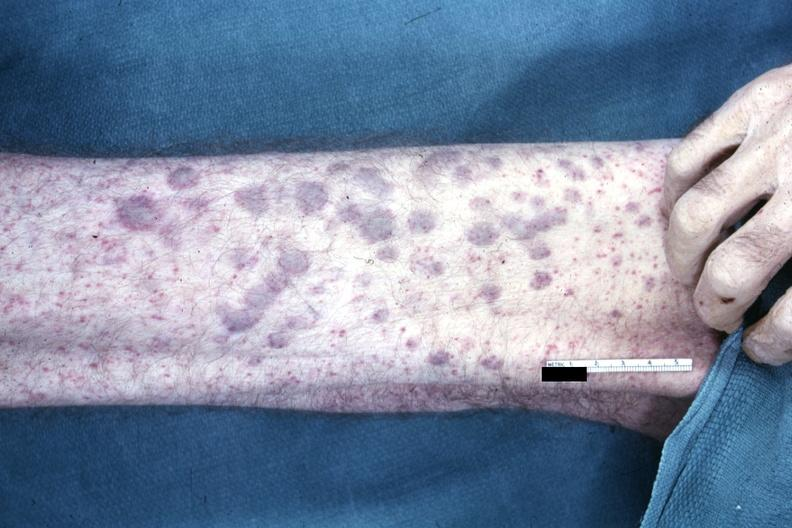s acute myelogenous leukemia present?
Answer the question using a single word or phrase. Yes 